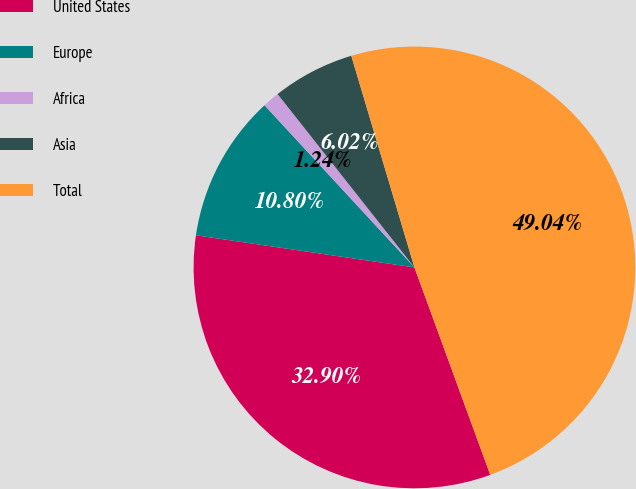<chart> <loc_0><loc_0><loc_500><loc_500><pie_chart><fcel>United States<fcel>Europe<fcel>Africa<fcel>Asia<fcel>Total<nl><fcel>32.9%<fcel>10.8%<fcel>1.24%<fcel>6.02%<fcel>49.04%<nl></chart> 